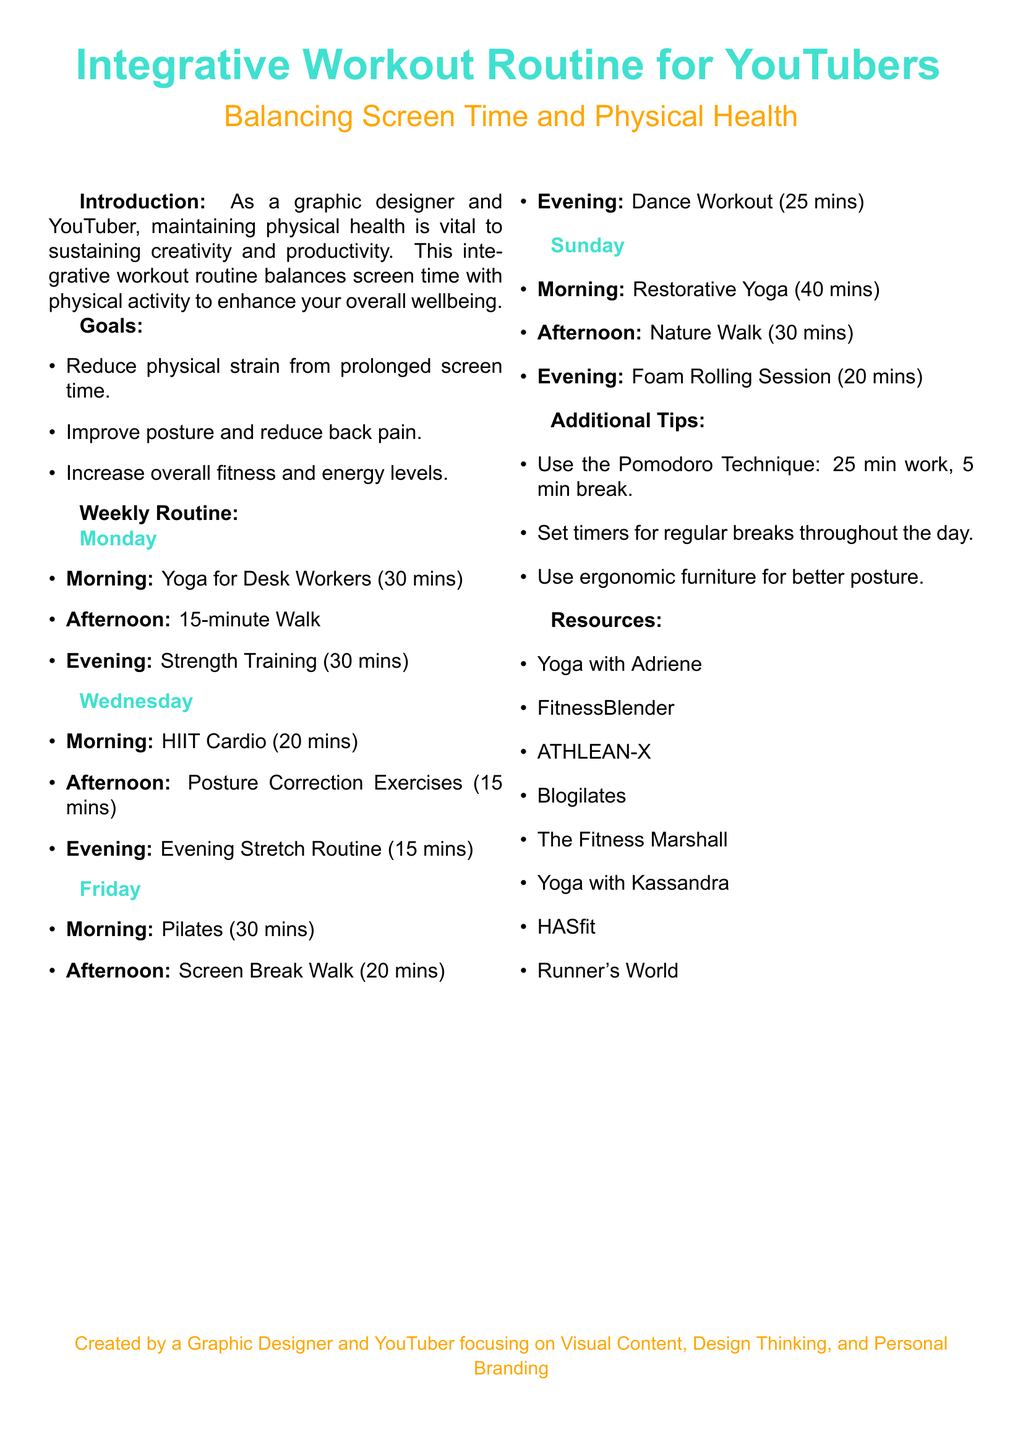What is the main purpose of the workout routine? The document states that the main purpose is to maintain physical health vital to sustaining creativity and productivity.
Answer: Maintain physical health How many minutes is the Yoga for Desk Workers session on Monday? The document specifies that the Yoga for Desk Workers session is 30 minutes long.
Answer: 30 mins What type of workout is scheduled for Friday evening? The document lists the workout scheduled for Friday evening as a Dance Workout.
Answer: Dance Workout Which exercise is recommended for Wednesday morning? The document indicates that HIIT Cardio is recommended for Wednesday morning.
Answer: HIIT Cardio What is one of the additional tips provided? The document lists several tips, one of which is to use the Pomodoro Technique.
Answer: Use the Pomodoro Technique How many minutes is the restorative yoga session on Sunday? The document states that the restorative yoga session lasts for 40 minutes on Sunday.
Answer: 40 mins What is the duration of the Foam Rolling Session in the evening on Sunday? The document mentions that the Foam Rolling Session is 20 minutes long on Sunday evening.
Answer: 20 mins Which online resource is suggested for Pilates workouts? The document specifies Blogilates as a resource for Pilates workouts.
Answer: Blogilates How many days are workouts scheduled in a week according to the document? The document indicates that workouts are scheduled for four days a week.
Answer: Four days 